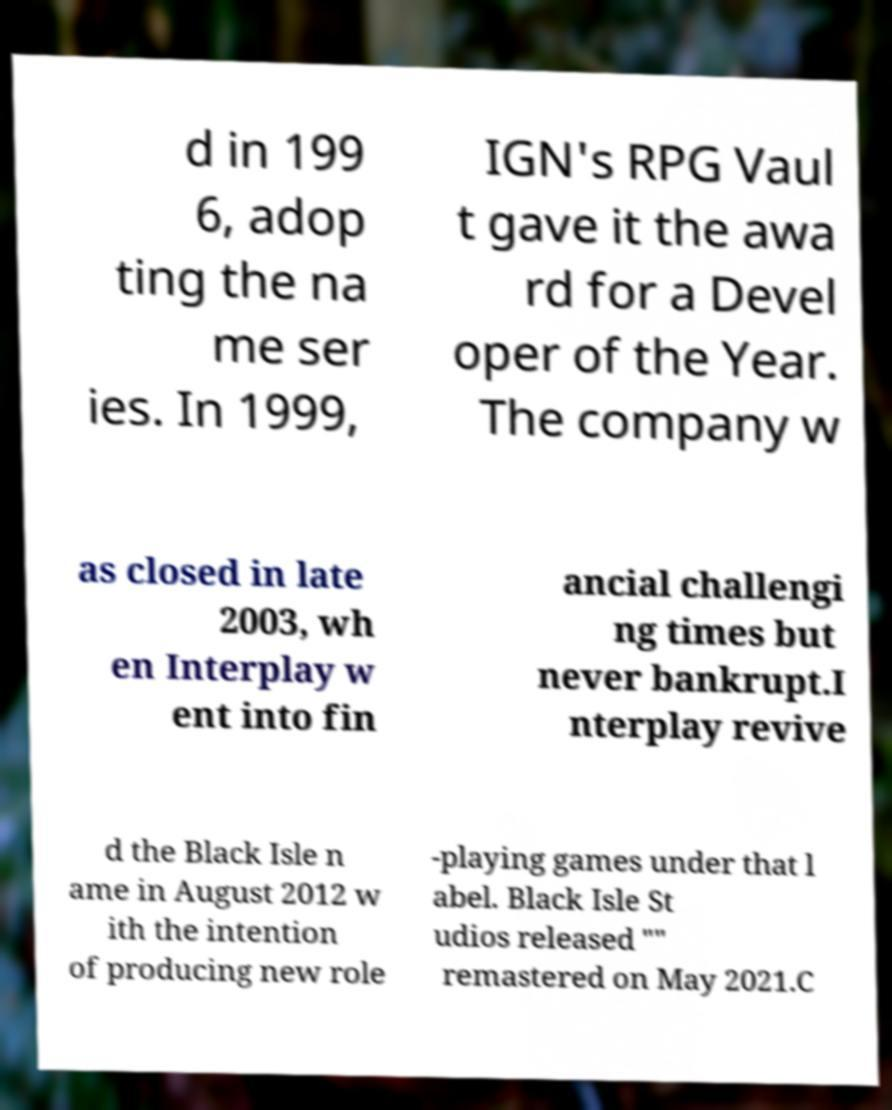Could you assist in decoding the text presented in this image and type it out clearly? d in 199 6, adop ting the na me ser ies. In 1999, IGN's RPG Vaul t gave it the awa rd for a Devel oper of the Year. The company w as closed in late 2003, wh en Interplay w ent into fin ancial challengi ng times but never bankrupt.I nterplay revive d the Black Isle n ame in August 2012 w ith the intention of producing new role -playing games under that l abel. Black Isle St udios released "" remastered on May 2021.C 